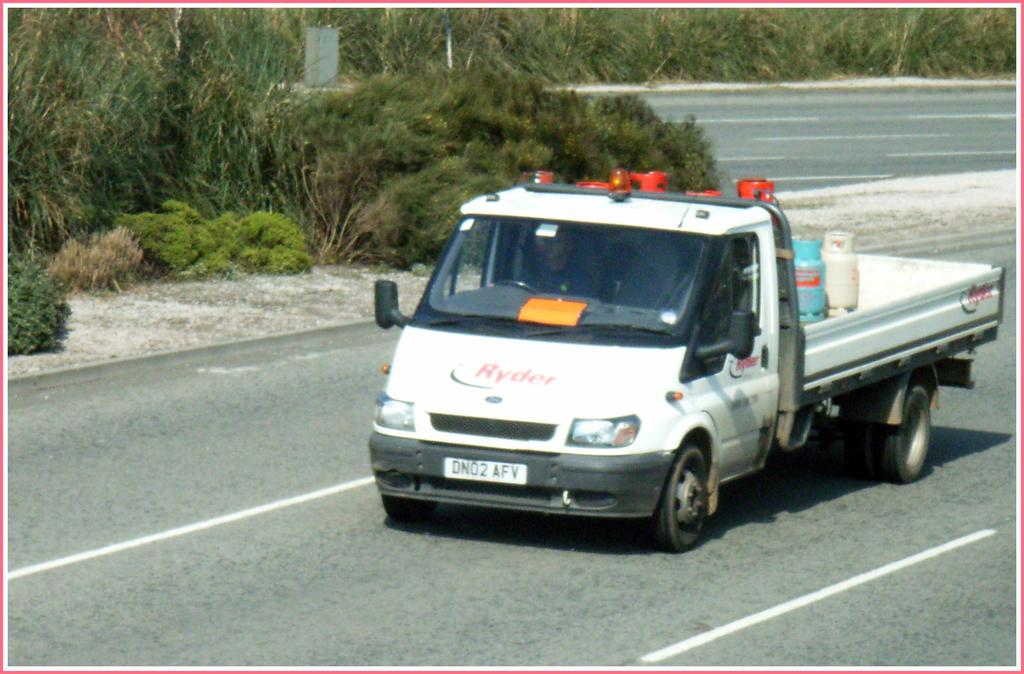What is the main subject in the foreground of the image? There is a van in the foreground of the image. What is the van doing in the image? The van is moving on the road. What can be seen on the van? There are cylinders on the van. What is visible in the background of the image? There are plants and a road visible in the background of the image. What type of playground equipment can be seen in the image? There is no playground equipment present in the image. How many feet are visible in the image? There are no feet visible in the image. 